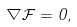Convert formula to latex. <formula><loc_0><loc_0><loc_500><loc_500>\nabla { \mathcal { F } } = 0 ,</formula> 